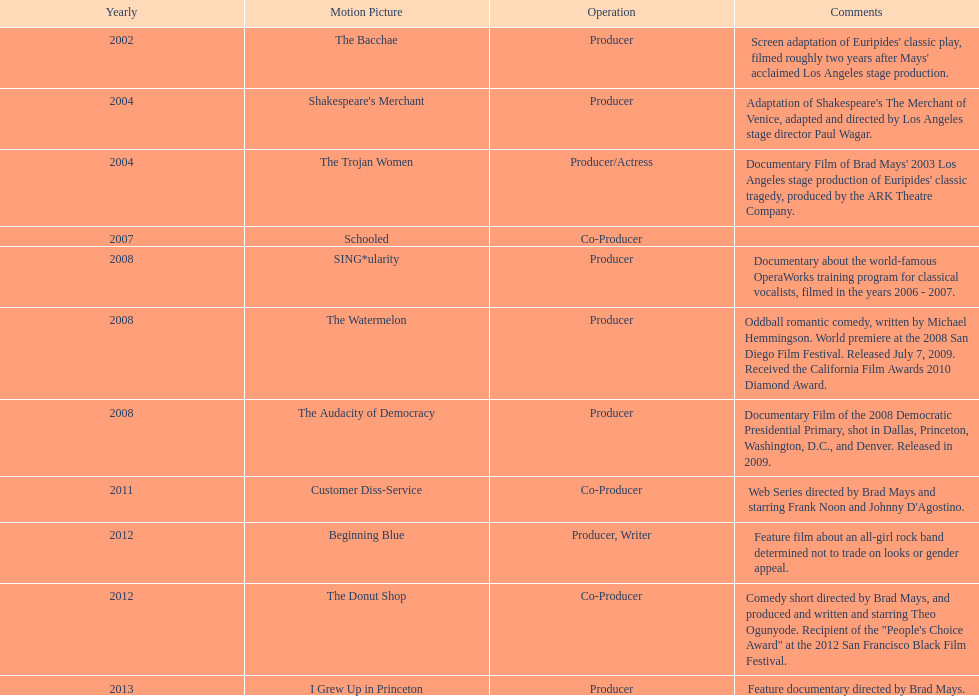How long was the film schooled out before beginning blue? 5 years. 